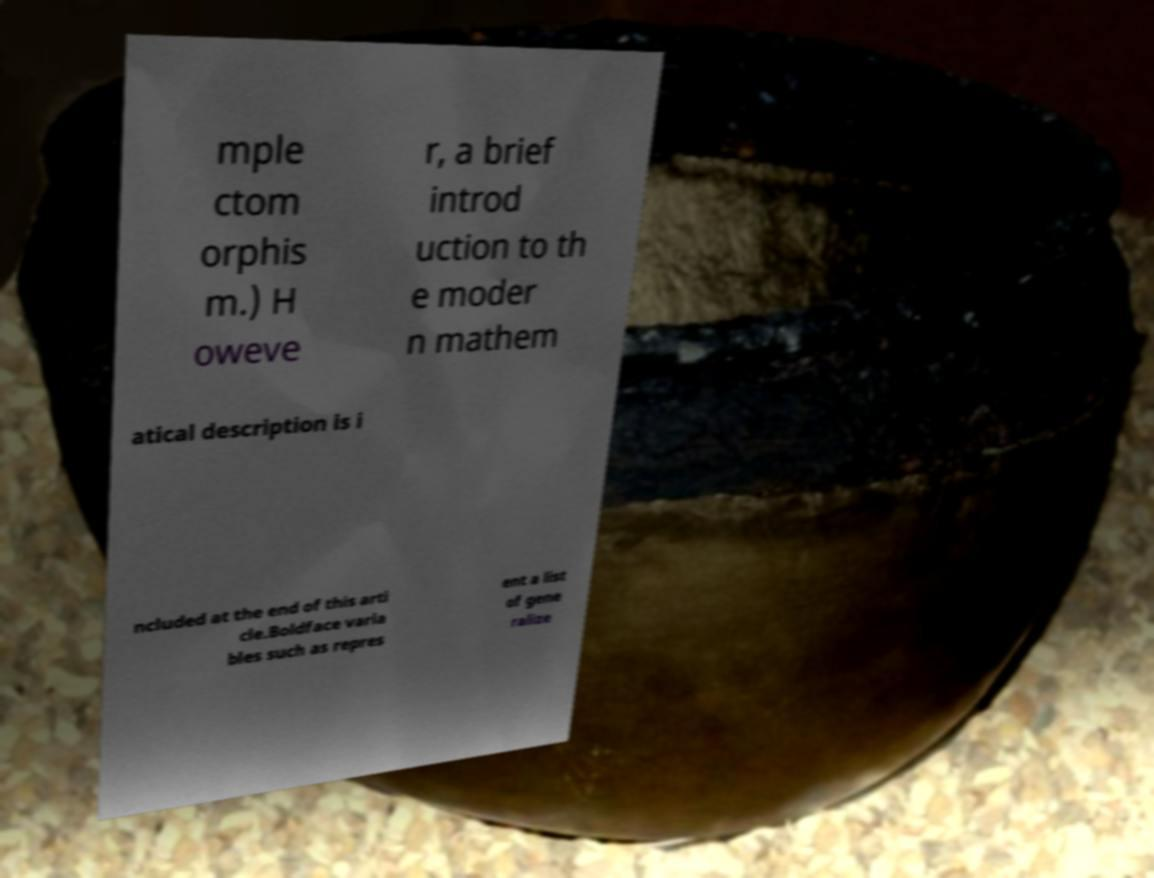For documentation purposes, I need the text within this image transcribed. Could you provide that? mple ctom orphis m.) H oweve r, a brief introd uction to th e moder n mathem atical description is i ncluded at the end of this arti cle.Boldface varia bles such as repres ent a list of gene ralize 